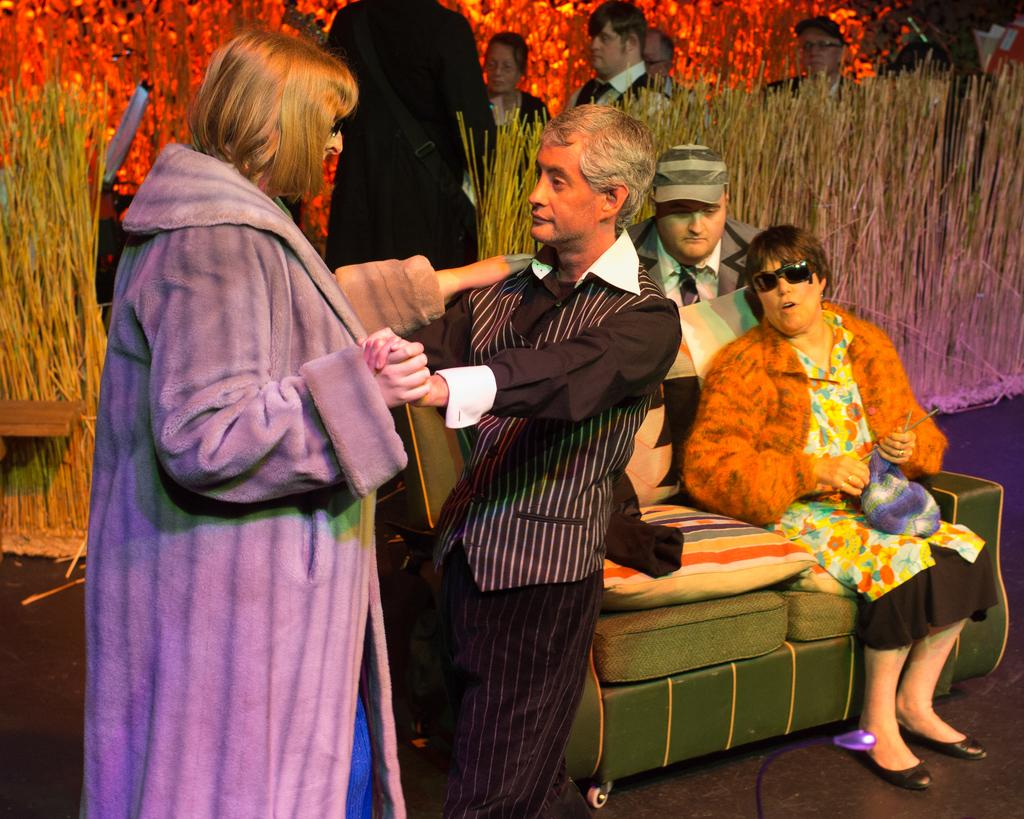What are the people in the image doing? There are people standing and sitting on a couch in the image. Can you describe the environment in the image? There is dry grass visible behind the people, and there are other items visible in the background. What type of string is being used to tell a joke in the image? There is no string or joke present in the image; it features people standing and sitting on a couch. How many thumbs can be seen in the image? The number of thumbs visible in the image cannot be determined from the provided facts. 